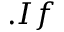Convert formula to latex. <formula><loc_0><loc_0><loc_500><loc_500>. I f</formula> 